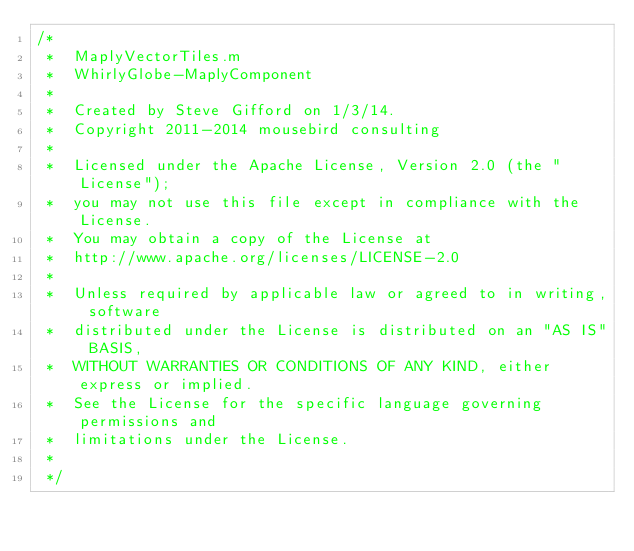Convert code to text. <code><loc_0><loc_0><loc_500><loc_500><_ObjectiveC_>/*
 *  MaplyVectorTiles.m
 *  WhirlyGlobe-MaplyComponent
 *
 *  Created by Steve Gifford on 1/3/14.
 *  Copyright 2011-2014 mousebird consulting
 *
 *  Licensed under the Apache License, Version 2.0 (the "License");
 *  you may not use this file except in compliance with the License.
 *  You may obtain a copy of the License at
 *  http://www.apache.org/licenses/LICENSE-2.0
 *
 *  Unless required by applicable law or agreed to in writing, software
 *  distributed under the License is distributed on an "AS IS" BASIS,
 *  WITHOUT WARRANTIES OR CONDITIONS OF ANY KIND, either express or implied.
 *  See the License for the specific language governing permissions and
 *  limitations under the License.
 *
 */
</code> 